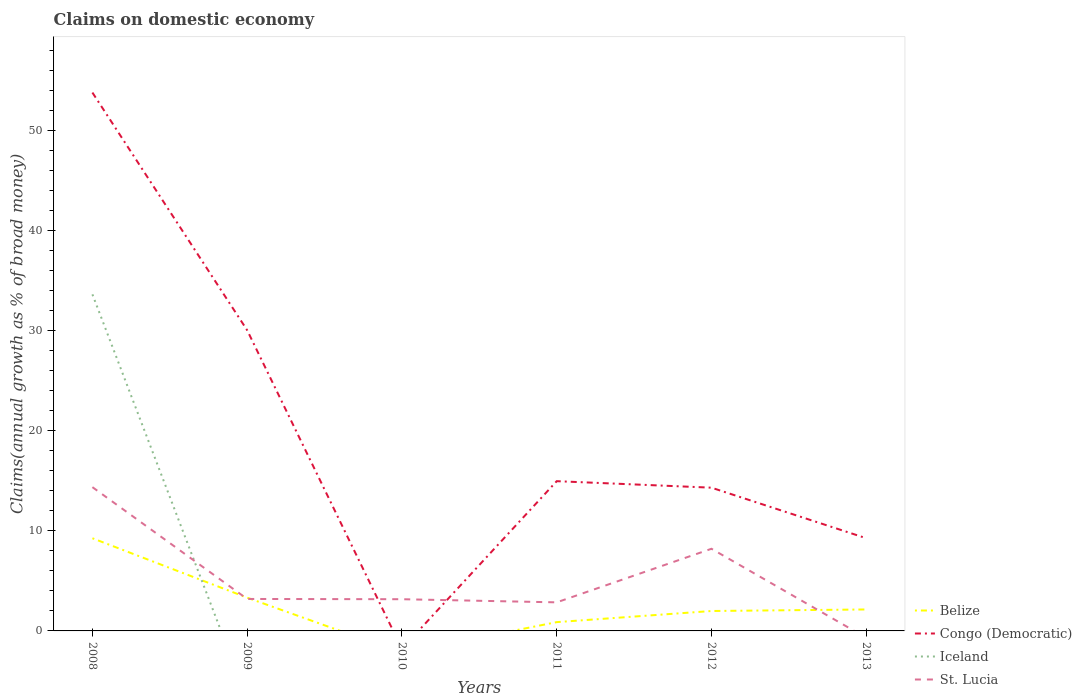How many different coloured lines are there?
Keep it short and to the point. 4. Does the line corresponding to Congo (Democratic) intersect with the line corresponding to Belize?
Provide a succinct answer. No. What is the total percentage of broad money claimed on domestic economy in Belize in the graph?
Keep it short and to the point. 5.94. What is the difference between the highest and the second highest percentage of broad money claimed on domestic economy in Congo (Democratic)?
Give a very brief answer. 53.8. Does the graph contain any zero values?
Your response must be concise. Yes. Does the graph contain grids?
Make the answer very short. No. Where does the legend appear in the graph?
Your answer should be compact. Bottom right. How many legend labels are there?
Ensure brevity in your answer.  4. How are the legend labels stacked?
Provide a short and direct response. Vertical. What is the title of the graph?
Provide a short and direct response. Claims on domestic economy. Does "OECD members" appear as one of the legend labels in the graph?
Your answer should be very brief. No. What is the label or title of the X-axis?
Keep it short and to the point. Years. What is the label or title of the Y-axis?
Provide a short and direct response. Claims(annual growth as % of broad money). What is the Claims(annual growth as % of broad money) of Belize in 2008?
Provide a succinct answer. 9.26. What is the Claims(annual growth as % of broad money) in Congo (Democratic) in 2008?
Your response must be concise. 53.8. What is the Claims(annual growth as % of broad money) of Iceland in 2008?
Give a very brief answer. 33.63. What is the Claims(annual growth as % of broad money) in St. Lucia in 2008?
Provide a succinct answer. 14.37. What is the Claims(annual growth as % of broad money) in Belize in 2009?
Keep it short and to the point. 3.32. What is the Claims(annual growth as % of broad money) of Congo (Democratic) in 2009?
Your answer should be very brief. 30.05. What is the Claims(annual growth as % of broad money) in Iceland in 2009?
Provide a short and direct response. 0. What is the Claims(annual growth as % of broad money) of St. Lucia in 2009?
Provide a short and direct response. 3.19. What is the Claims(annual growth as % of broad money) in Belize in 2010?
Your answer should be very brief. 0. What is the Claims(annual growth as % of broad money) of St. Lucia in 2010?
Provide a succinct answer. 3.17. What is the Claims(annual growth as % of broad money) of Belize in 2011?
Give a very brief answer. 0.88. What is the Claims(annual growth as % of broad money) in Congo (Democratic) in 2011?
Give a very brief answer. 14.96. What is the Claims(annual growth as % of broad money) in St. Lucia in 2011?
Offer a very short reply. 2.86. What is the Claims(annual growth as % of broad money) in Belize in 2012?
Ensure brevity in your answer.  1.99. What is the Claims(annual growth as % of broad money) of Congo (Democratic) in 2012?
Provide a short and direct response. 14.31. What is the Claims(annual growth as % of broad money) of Iceland in 2012?
Your answer should be compact. 0. What is the Claims(annual growth as % of broad money) of St. Lucia in 2012?
Offer a terse response. 8.21. What is the Claims(annual growth as % of broad money) in Belize in 2013?
Make the answer very short. 2.14. What is the Claims(annual growth as % of broad money) in Congo (Democratic) in 2013?
Keep it short and to the point. 9.26. Across all years, what is the maximum Claims(annual growth as % of broad money) in Belize?
Give a very brief answer. 9.26. Across all years, what is the maximum Claims(annual growth as % of broad money) of Congo (Democratic)?
Offer a very short reply. 53.8. Across all years, what is the maximum Claims(annual growth as % of broad money) of Iceland?
Give a very brief answer. 33.63. Across all years, what is the maximum Claims(annual growth as % of broad money) of St. Lucia?
Offer a terse response. 14.37. Across all years, what is the minimum Claims(annual growth as % of broad money) of Belize?
Provide a succinct answer. 0. Across all years, what is the minimum Claims(annual growth as % of broad money) in Congo (Democratic)?
Provide a short and direct response. 0. What is the total Claims(annual growth as % of broad money) in Belize in the graph?
Give a very brief answer. 17.6. What is the total Claims(annual growth as % of broad money) in Congo (Democratic) in the graph?
Keep it short and to the point. 122.39. What is the total Claims(annual growth as % of broad money) in Iceland in the graph?
Provide a succinct answer. 33.63. What is the total Claims(annual growth as % of broad money) in St. Lucia in the graph?
Keep it short and to the point. 31.79. What is the difference between the Claims(annual growth as % of broad money) in Belize in 2008 and that in 2009?
Offer a terse response. 5.94. What is the difference between the Claims(annual growth as % of broad money) of Congo (Democratic) in 2008 and that in 2009?
Your answer should be compact. 23.75. What is the difference between the Claims(annual growth as % of broad money) in St. Lucia in 2008 and that in 2009?
Keep it short and to the point. 11.17. What is the difference between the Claims(annual growth as % of broad money) of St. Lucia in 2008 and that in 2010?
Your response must be concise. 11.2. What is the difference between the Claims(annual growth as % of broad money) of Belize in 2008 and that in 2011?
Offer a terse response. 8.38. What is the difference between the Claims(annual growth as % of broad money) in Congo (Democratic) in 2008 and that in 2011?
Give a very brief answer. 38.83. What is the difference between the Claims(annual growth as % of broad money) in St. Lucia in 2008 and that in 2011?
Your answer should be compact. 11.51. What is the difference between the Claims(annual growth as % of broad money) in Belize in 2008 and that in 2012?
Give a very brief answer. 7.27. What is the difference between the Claims(annual growth as % of broad money) of Congo (Democratic) in 2008 and that in 2012?
Provide a succinct answer. 39.48. What is the difference between the Claims(annual growth as % of broad money) in St. Lucia in 2008 and that in 2012?
Ensure brevity in your answer.  6.16. What is the difference between the Claims(annual growth as % of broad money) of Belize in 2008 and that in 2013?
Make the answer very short. 7.12. What is the difference between the Claims(annual growth as % of broad money) of Congo (Democratic) in 2008 and that in 2013?
Your answer should be compact. 44.53. What is the difference between the Claims(annual growth as % of broad money) of St. Lucia in 2009 and that in 2010?
Provide a short and direct response. 0.03. What is the difference between the Claims(annual growth as % of broad money) of Belize in 2009 and that in 2011?
Your answer should be very brief. 2.44. What is the difference between the Claims(annual growth as % of broad money) in Congo (Democratic) in 2009 and that in 2011?
Keep it short and to the point. 15.08. What is the difference between the Claims(annual growth as % of broad money) in St. Lucia in 2009 and that in 2011?
Make the answer very short. 0.34. What is the difference between the Claims(annual growth as % of broad money) of Belize in 2009 and that in 2012?
Your response must be concise. 1.33. What is the difference between the Claims(annual growth as % of broad money) in Congo (Democratic) in 2009 and that in 2012?
Your answer should be very brief. 15.73. What is the difference between the Claims(annual growth as % of broad money) of St. Lucia in 2009 and that in 2012?
Your answer should be compact. -5.01. What is the difference between the Claims(annual growth as % of broad money) of Belize in 2009 and that in 2013?
Give a very brief answer. 1.18. What is the difference between the Claims(annual growth as % of broad money) of Congo (Democratic) in 2009 and that in 2013?
Ensure brevity in your answer.  20.78. What is the difference between the Claims(annual growth as % of broad money) in St. Lucia in 2010 and that in 2011?
Your answer should be very brief. 0.31. What is the difference between the Claims(annual growth as % of broad money) in St. Lucia in 2010 and that in 2012?
Offer a very short reply. -5.04. What is the difference between the Claims(annual growth as % of broad money) of Belize in 2011 and that in 2012?
Your answer should be very brief. -1.11. What is the difference between the Claims(annual growth as % of broad money) in Congo (Democratic) in 2011 and that in 2012?
Keep it short and to the point. 0.65. What is the difference between the Claims(annual growth as % of broad money) in St. Lucia in 2011 and that in 2012?
Ensure brevity in your answer.  -5.35. What is the difference between the Claims(annual growth as % of broad money) of Belize in 2011 and that in 2013?
Offer a very short reply. -1.27. What is the difference between the Claims(annual growth as % of broad money) in Congo (Democratic) in 2011 and that in 2013?
Your response must be concise. 5.7. What is the difference between the Claims(annual growth as % of broad money) of Belize in 2012 and that in 2013?
Give a very brief answer. -0.15. What is the difference between the Claims(annual growth as % of broad money) in Congo (Democratic) in 2012 and that in 2013?
Keep it short and to the point. 5.05. What is the difference between the Claims(annual growth as % of broad money) of Belize in 2008 and the Claims(annual growth as % of broad money) of Congo (Democratic) in 2009?
Your answer should be very brief. -20.79. What is the difference between the Claims(annual growth as % of broad money) of Belize in 2008 and the Claims(annual growth as % of broad money) of St. Lucia in 2009?
Offer a terse response. 6.07. What is the difference between the Claims(annual growth as % of broad money) of Congo (Democratic) in 2008 and the Claims(annual growth as % of broad money) of St. Lucia in 2009?
Offer a terse response. 50.6. What is the difference between the Claims(annual growth as % of broad money) of Iceland in 2008 and the Claims(annual growth as % of broad money) of St. Lucia in 2009?
Offer a terse response. 30.44. What is the difference between the Claims(annual growth as % of broad money) of Belize in 2008 and the Claims(annual growth as % of broad money) of St. Lucia in 2010?
Your response must be concise. 6.09. What is the difference between the Claims(annual growth as % of broad money) in Congo (Democratic) in 2008 and the Claims(annual growth as % of broad money) in St. Lucia in 2010?
Offer a terse response. 50.63. What is the difference between the Claims(annual growth as % of broad money) in Iceland in 2008 and the Claims(annual growth as % of broad money) in St. Lucia in 2010?
Your response must be concise. 30.46. What is the difference between the Claims(annual growth as % of broad money) of Belize in 2008 and the Claims(annual growth as % of broad money) of Congo (Democratic) in 2011?
Your answer should be very brief. -5.7. What is the difference between the Claims(annual growth as % of broad money) in Belize in 2008 and the Claims(annual growth as % of broad money) in St. Lucia in 2011?
Keep it short and to the point. 6.41. What is the difference between the Claims(annual growth as % of broad money) of Congo (Democratic) in 2008 and the Claims(annual growth as % of broad money) of St. Lucia in 2011?
Provide a succinct answer. 50.94. What is the difference between the Claims(annual growth as % of broad money) of Iceland in 2008 and the Claims(annual growth as % of broad money) of St. Lucia in 2011?
Your answer should be very brief. 30.78. What is the difference between the Claims(annual growth as % of broad money) of Belize in 2008 and the Claims(annual growth as % of broad money) of Congo (Democratic) in 2012?
Your answer should be compact. -5.05. What is the difference between the Claims(annual growth as % of broad money) of Belize in 2008 and the Claims(annual growth as % of broad money) of St. Lucia in 2012?
Provide a short and direct response. 1.05. What is the difference between the Claims(annual growth as % of broad money) in Congo (Democratic) in 2008 and the Claims(annual growth as % of broad money) in St. Lucia in 2012?
Offer a very short reply. 45.59. What is the difference between the Claims(annual growth as % of broad money) in Iceland in 2008 and the Claims(annual growth as % of broad money) in St. Lucia in 2012?
Provide a succinct answer. 25.42. What is the difference between the Claims(annual growth as % of broad money) in Belize in 2008 and the Claims(annual growth as % of broad money) in Congo (Democratic) in 2013?
Your answer should be very brief. -0. What is the difference between the Claims(annual growth as % of broad money) in Belize in 2009 and the Claims(annual growth as % of broad money) in St. Lucia in 2010?
Your answer should be very brief. 0.15. What is the difference between the Claims(annual growth as % of broad money) of Congo (Democratic) in 2009 and the Claims(annual growth as % of broad money) of St. Lucia in 2010?
Your answer should be compact. 26.88. What is the difference between the Claims(annual growth as % of broad money) in Belize in 2009 and the Claims(annual growth as % of broad money) in Congo (Democratic) in 2011?
Your answer should be compact. -11.64. What is the difference between the Claims(annual growth as % of broad money) of Belize in 2009 and the Claims(annual growth as % of broad money) of St. Lucia in 2011?
Ensure brevity in your answer.  0.47. What is the difference between the Claims(annual growth as % of broad money) in Congo (Democratic) in 2009 and the Claims(annual growth as % of broad money) in St. Lucia in 2011?
Offer a very short reply. 27.19. What is the difference between the Claims(annual growth as % of broad money) of Belize in 2009 and the Claims(annual growth as % of broad money) of Congo (Democratic) in 2012?
Your answer should be very brief. -10.99. What is the difference between the Claims(annual growth as % of broad money) in Belize in 2009 and the Claims(annual growth as % of broad money) in St. Lucia in 2012?
Offer a very short reply. -4.89. What is the difference between the Claims(annual growth as % of broad money) in Congo (Democratic) in 2009 and the Claims(annual growth as % of broad money) in St. Lucia in 2012?
Offer a very short reply. 21.84. What is the difference between the Claims(annual growth as % of broad money) in Belize in 2009 and the Claims(annual growth as % of broad money) in Congo (Democratic) in 2013?
Provide a short and direct response. -5.94. What is the difference between the Claims(annual growth as % of broad money) in Belize in 2011 and the Claims(annual growth as % of broad money) in Congo (Democratic) in 2012?
Provide a succinct answer. -13.44. What is the difference between the Claims(annual growth as % of broad money) in Belize in 2011 and the Claims(annual growth as % of broad money) in St. Lucia in 2012?
Give a very brief answer. -7.33. What is the difference between the Claims(annual growth as % of broad money) in Congo (Democratic) in 2011 and the Claims(annual growth as % of broad money) in St. Lucia in 2012?
Give a very brief answer. 6.76. What is the difference between the Claims(annual growth as % of broad money) of Belize in 2011 and the Claims(annual growth as % of broad money) of Congo (Democratic) in 2013?
Provide a succinct answer. -8.39. What is the difference between the Claims(annual growth as % of broad money) in Belize in 2012 and the Claims(annual growth as % of broad money) in Congo (Democratic) in 2013?
Give a very brief answer. -7.27. What is the average Claims(annual growth as % of broad money) of Belize per year?
Give a very brief answer. 2.93. What is the average Claims(annual growth as % of broad money) of Congo (Democratic) per year?
Make the answer very short. 20.4. What is the average Claims(annual growth as % of broad money) of Iceland per year?
Provide a short and direct response. 5.61. What is the average Claims(annual growth as % of broad money) in St. Lucia per year?
Your answer should be compact. 5.3. In the year 2008, what is the difference between the Claims(annual growth as % of broad money) in Belize and Claims(annual growth as % of broad money) in Congo (Democratic)?
Offer a terse response. -44.54. In the year 2008, what is the difference between the Claims(annual growth as % of broad money) of Belize and Claims(annual growth as % of broad money) of Iceland?
Your answer should be very brief. -24.37. In the year 2008, what is the difference between the Claims(annual growth as % of broad money) in Belize and Claims(annual growth as % of broad money) in St. Lucia?
Give a very brief answer. -5.11. In the year 2008, what is the difference between the Claims(annual growth as % of broad money) of Congo (Democratic) and Claims(annual growth as % of broad money) of Iceland?
Offer a terse response. 20.16. In the year 2008, what is the difference between the Claims(annual growth as % of broad money) in Congo (Democratic) and Claims(annual growth as % of broad money) in St. Lucia?
Your answer should be very brief. 39.43. In the year 2008, what is the difference between the Claims(annual growth as % of broad money) of Iceland and Claims(annual growth as % of broad money) of St. Lucia?
Ensure brevity in your answer.  19.27. In the year 2009, what is the difference between the Claims(annual growth as % of broad money) of Belize and Claims(annual growth as % of broad money) of Congo (Democratic)?
Ensure brevity in your answer.  -26.73. In the year 2009, what is the difference between the Claims(annual growth as % of broad money) in Belize and Claims(annual growth as % of broad money) in St. Lucia?
Provide a short and direct response. 0.13. In the year 2009, what is the difference between the Claims(annual growth as % of broad money) in Congo (Democratic) and Claims(annual growth as % of broad money) in St. Lucia?
Ensure brevity in your answer.  26.85. In the year 2011, what is the difference between the Claims(annual growth as % of broad money) in Belize and Claims(annual growth as % of broad money) in Congo (Democratic)?
Give a very brief answer. -14.09. In the year 2011, what is the difference between the Claims(annual growth as % of broad money) in Belize and Claims(annual growth as % of broad money) in St. Lucia?
Your response must be concise. -1.98. In the year 2011, what is the difference between the Claims(annual growth as % of broad money) in Congo (Democratic) and Claims(annual growth as % of broad money) in St. Lucia?
Your response must be concise. 12.11. In the year 2012, what is the difference between the Claims(annual growth as % of broad money) of Belize and Claims(annual growth as % of broad money) of Congo (Democratic)?
Offer a very short reply. -12.32. In the year 2012, what is the difference between the Claims(annual growth as % of broad money) of Belize and Claims(annual growth as % of broad money) of St. Lucia?
Ensure brevity in your answer.  -6.22. In the year 2012, what is the difference between the Claims(annual growth as % of broad money) of Congo (Democratic) and Claims(annual growth as % of broad money) of St. Lucia?
Your answer should be very brief. 6.11. In the year 2013, what is the difference between the Claims(annual growth as % of broad money) in Belize and Claims(annual growth as % of broad money) in Congo (Democratic)?
Your answer should be very brief. -7.12. What is the ratio of the Claims(annual growth as % of broad money) of Belize in 2008 to that in 2009?
Your response must be concise. 2.79. What is the ratio of the Claims(annual growth as % of broad money) of Congo (Democratic) in 2008 to that in 2009?
Make the answer very short. 1.79. What is the ratio of the Claims(annual growth as % of broad money) in St. Lucia in 2008 to that in 2009?
Your answer should be very brief. 4.5. What is the ratio of the Claims(annual growth as % of broad money) of St. Lucia in 2008 to that in 2010?
Your answer should be very brief. 4.53. What is the ratio of the Claims(annual growth as % of broad money) in Belize in 2008 to that in 2011?
Offer a terse response. 10.54. What is the ratio of the Claims(annual growth as % of broad money) of Congo (Democratic) in 2008 to that in 2011?
Provide a short and direct response. 3.6. What is the ratio of the Claims(annual growth as % of broad money) of St. Lucia in 2008 to that in 2011?
Keep it short and to the point. 5.03. What is the ratio of the Claims(annual growth as % of broad money) in Belize in 2008 to that in 2012?
Your response must be concise. 4.65. What is the ratio of the Claims(annual growth as % of broad money) in Congo (Democratic) in 2008 to that in 2012?
Ensure brevity in your answer.  3.76. What is the ratio of the Claims(annual growth as % of broad money) of St. Lucia in 2008 to that in 2012?
Offer a very short reply. 1.75. What is the ratio of the Claims(annual growth as % of broad money) of Belize in 2008 to that in 2013?
Give a very brief answer. 4.32. What is the ratio of the Claims(annual growth as % of broad money) in Congo (Democratic) in 2008 to that in 2013?
Give a very brief answer. 5.81. What is the ratio of the Claims(annual growth as % of broad money) in Belize in 2009 to that in 2011?
Offer a very short reply. 3.78. What is the ratio of the Claims(annual growth as % of broad money) in Congo (Democratic) in 2009 to that in 2011?
Keep it short and to the point. 2.01. What is the ratio of the Claims(annual growth as % of broad money) of St. Lucia in 2009 to that in 2011?
Your answer should be very brief. 1.12. What is the ratio of the Claims(annual growth as % of broad money) in Belize in 2009 to that in 2012?
Give a very brief answer. 1.67. What is the ratio of the Claims(annual growth as % of broad money) in Congo (Democratic) in 2009 to that in 2012?
Your answer should be very brief. 2.1. What is the ratio of the Claims(annual growth as % of broad money) in St. Lucia in 2009 to that in 2012?
Offer a terse response. 0.39. What is the ratio of the Claims(annual growth as % of broad money) in Belize in 2009 to that in 2013?
Give a very brief answer. 1.55. What is the ratio of the Claims(annual growth as % of broad money) of Congo (Democratic) in 2009 to that in 2013?
Your answer should be compact. 3.24. What is the ratio of the Claims(annual growth as % of broad money) in St. Lucia in 2010 to that in 2011?
Keep it short and to the point. 1.11. What is the ratio of the Claims(annual growth as % of broad money) of St. Lucia in 2010 to that in 2012?
Keep it short and to the point. 0.39. What is the ratio of the Claims(annual growth as % of broad money) of Belize in 2011 to that in 2012?
Provide a succinct answer. 0.44. What is the ratio of the Claims(annual growth as % of broad money) of Congo (Democratic) in 2011 to that in 2012?
Keep it short and to the point. 1.05. What is the ratio of the Claims(annual growth as % of broad money) in St. Lucia in 2011 to that in 2012?
Offer a terse response. 0.35. What is the ratio of the Claims(annual growth as % of broad money) of Belize in 2011 to that in 2013?
Your response must be concise. 0.41. What is the ratio of the Claims(annual growth as % of broad money) in Congo (Democratic) in 2011 to that in 2013?
Your answer should be very brief. 1.62. What is the ratio of the Claims(annual growth as % of broad money) of Belize in 2012 to that in 2013?
Your answer should be very brief. 0.93. What is the ratio of the Claims(annual growth as % of broad money) in Congo (Democratic) in 2012 to that in 2013?
Keep it short and to the point. 1.55. What is the difference between the highest and the second highest Claims(annual growth as % of broad money) of Belize?
Provide a succinct answer. 5.94. What is the difference between the highest and the second highest Claims(annual growth as % of broad money) of Congo (Democratic)?
Offer a terse response. 23.75. What is the difference between the highest and the second highest Claims(annual growth as % of broad money) of St. Lucia?
Your response must be concise. 6.16. What is the difference between the highest and the lowest Claims(annual growth as % of broad money) of Belize?
Your answer should be very brief. 9.26. What is the difference between the highest and the lowest Claims(annual growth as % of broad money) of Congo (Democratic)?
Provide a short and direct response. 53.8. What is the difference between the highest and the lowest Claims(annual growth as % of broad money) in Iceland?
Your answer should be very brief. 33.63. What is the difference between the highest and the lowest Claims(annual growth as % of broad money) in St. Lucia?
Give a very brief answer. 14.37. 